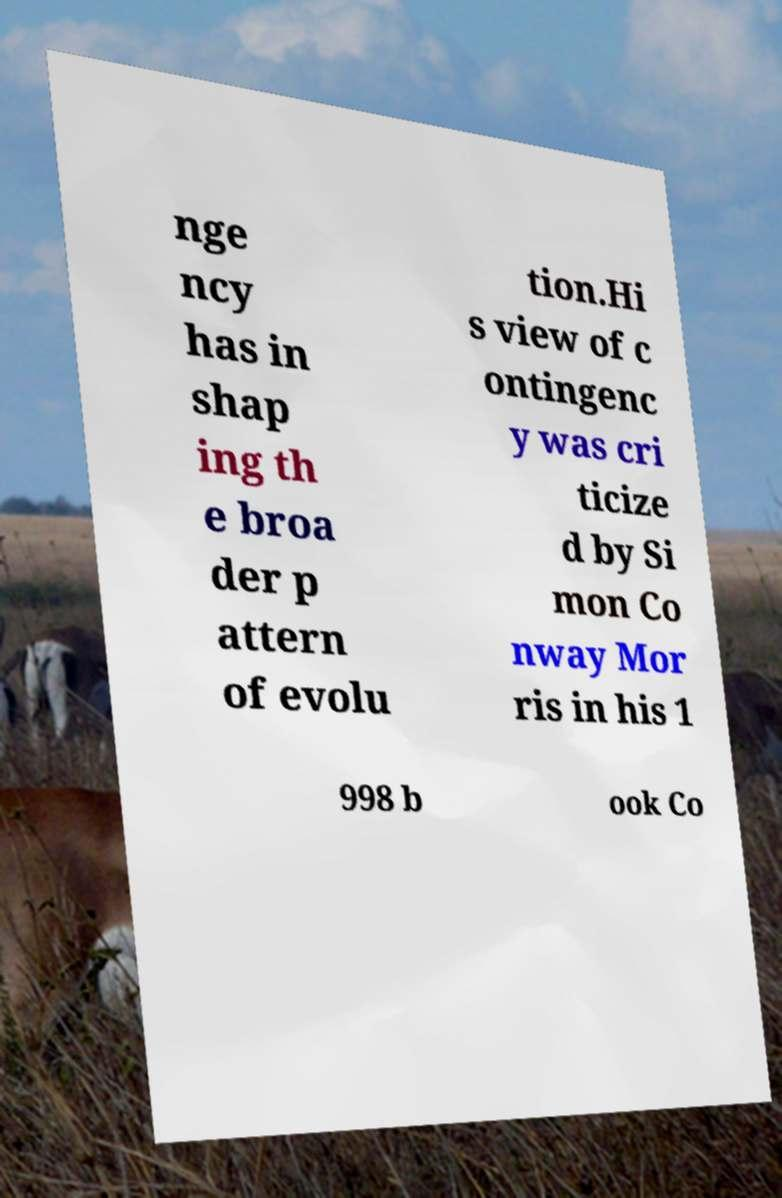Please identify and transcribe the text found in this image. nge ncy has in shap ing th e broa der p attern of evolu tion.Hi s view of c ontingenc y was cri ticize d by Si mon Co nway Mor ris in his 1 998 b ook Co 